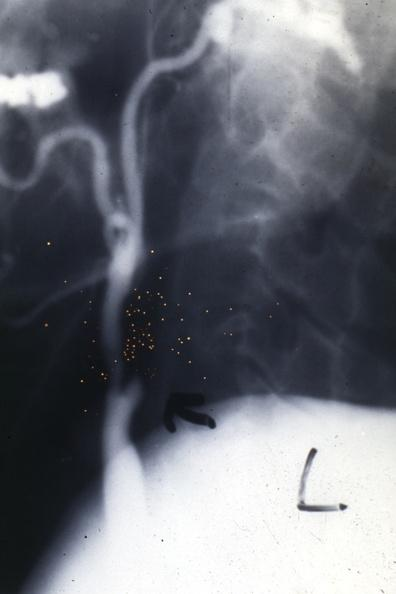s cardiovascular present?
Answer the question using a single word or phrase. Yes 